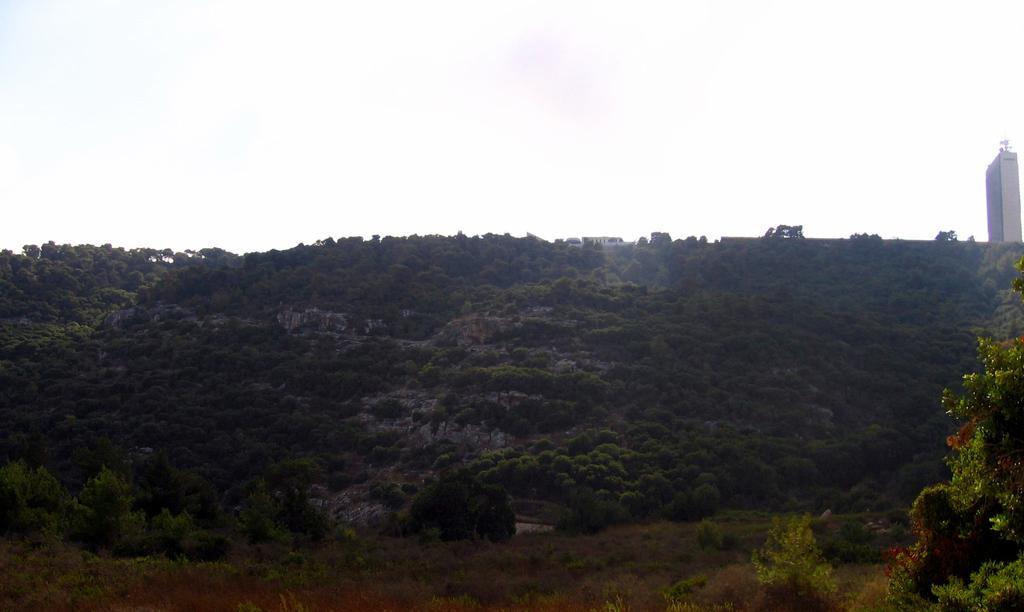Please provide a concise description of this image. In this image there are trees and there is a tower. 